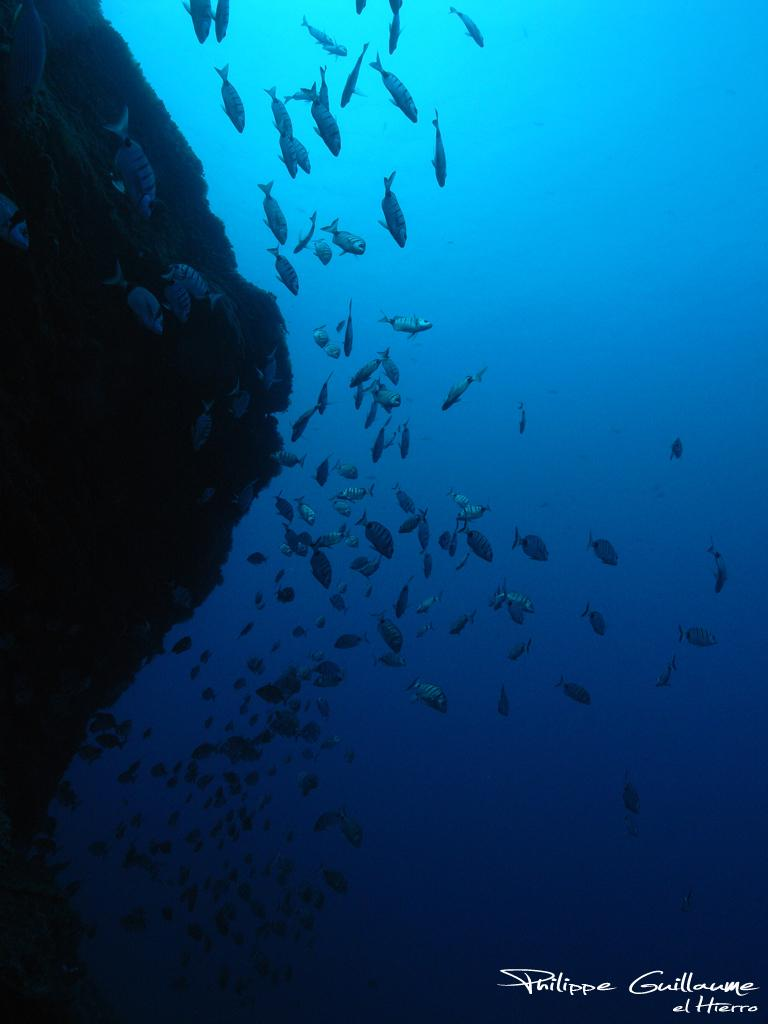What type of animals can be seen in the water in the image? There are huge fish in the water in the image. What other object can be seen in the image besides the fish? There is a rock in the image. Is there any text present in the image? Yes, there is some text at the bottom of the image. What is the taste of the rock in the image? Rocks do not have a taste, so this question cannot be answered definitively from the image. 